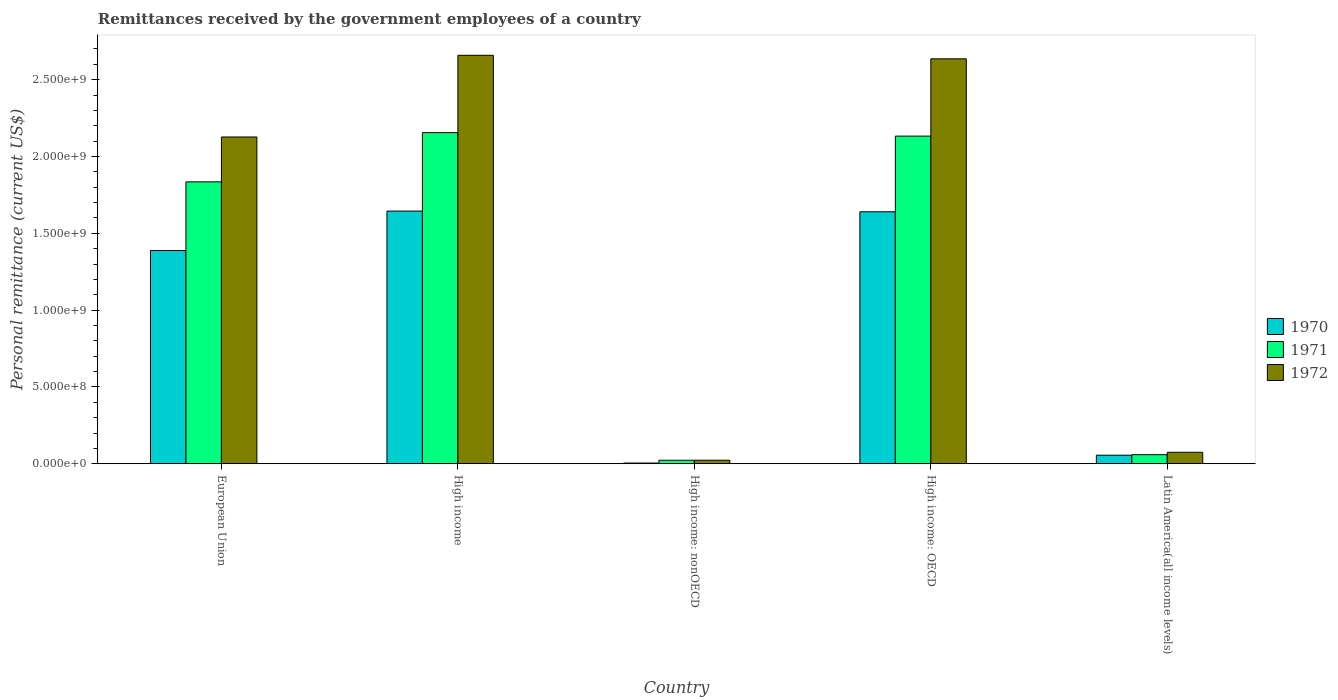Are the number of bars per tick equal to the number of legend labels?
Your answer should be very brief. Yes. Are the number of bars on each tick of the X-axis equal?
Provide a short and direct response. Yes. How many bars are there on the 4th tick from the left?
Your answer should be very brief. 3. How many bars are there on the 5th tick from the right?
Your response must be concise. 3. What is the label of the 5th group of bars from the left?
Provide a short and direct response. Latin America(all income levels). In how many cases, is the number of bars for a given country not equal to the number of legend labels?
Offer a terse response. 0. What is the remittances received by the government employees in 1972 in High income: nonOECD?
Give a very brief answer. 2.29e+07. Across all countries, what is the maximum remittances received by the government employees in 1971?
Offer a very short reply. 2.16e+09. Across all countries, what is the minimum remittances received by the government employees in 1971?
Provide a short and direct response. 2.28e+07. In which country was the remittances received by the government employees in 1971 maximum?
Make the answer very short. High income. In which country was the remittances received by the government employees in 1970 minimum?
Make the answer very short. High income: nonOECD. What is the total remittances received by the government employees in 1970 in the graph?
Your answer should be very brief. 4.73e+09. What is the difference between the remittances received by the government employees in 1972 in High income and that in High income: OECD?
Offer a terse response. 2.29e+07. What is the difference between the remittances received by the government employees in 1970 in High income: nonOECD and the remittances received by the government employees in 1971 in High income: OECD?
Ensure brevity in your answer.  -2.13e+09. What is the average remittances received by the government employees in 1971 per country?
Keep it short and to the point. 1.24e+09. What is the difference between the remittances received by the government employees of/in 1970 and remittances received by the government employees of/in 1971 in Latin America(all income levels)?
Provide a succinct answer. -3.57e+06. In how many countries, is the remittances received by the government employees in 1972 greater than 1200000000 US$?
Your response must be concise. 3. What is the ratio of the remittances received by the government employees in 1971 in European Union to that in High income: nonOECD?
Keep it short and to the point. 80.52. Is the difference between the remittances received by the government employees in 1970 in High income: OECD and Latin America(all income levels) greater than the difference between the remittances received by the government employees in 1971 in High income: OECD and Latin America(all income levels)?
Keep it short and to the point. No. What is the difference between the highest and the second highest remittances received by the government employees in 1971?
Your answer should be compact. 2.98e+08. What is the difference between the highest and the lowest remittances received by the government employees in 1972?
Provide a short and direct response. 2.64e+09. Is the sum of the remittances received by the government employees in 1971 in High income: OECD and Latin America(all income levels) greater than the maximum remittances received by the government employees in 1972 across all countries?
Provide a succinct answer. No. What does the 3rd bar from the left in High income represents?
Your response must be concise. 1972. Is it the case that in every country, the sum of the remittances received by the government employees in 1971 and remittances received by the government employees in 1972 is greater than the remittances received by the government employees in 1970?
Ensure brevity in your answer.  Yes. How many countries are there in the graph?
Ensure brevity in your answer.  5. Are the values on the major ticks of Y-axis written in scientific E-notation?
Your answer should be very brief. Yes. Does the graph contain any zero values?
Offer a very short reply. No. Does the graph contain grids?
Offer a terse response. No. What is the title of the graph?
Your response must be concise. Remittances received by the government employees of a country. What is the label or title of the X-axis?
Provide a succinct answer. Country. What is the label or title of the Y-axis?
Offer a terse response. Personal remittance (current US$). What is the Personal remittance (current US$) in 1970 in European Union?
Your answer should be very brief. 1.39e+09. What is the Personal remittance (current US$) in 1971 in European Union?
Keep it short and to the point. 1.83e+09. What is the Personal remittance (current US$) in 1972 in European Union?
Make the answer very short. 2.13e+09. What is the Personal remittance (current US$) in 1970 in High income?
Your response must be concise. 1.64e+09. What is the Personal remittance (current US$) of 1971 in High income?
Your response must be concise. 2.16e+09. What is the Personal remittance (current US$) in 1972 in High income?
Offer a very short reply. 2.66e+09. What is the Personal remittance (current US$) of 1970 in High income: nonOECD?
Give a very brief answer. 4.40e+06. What is the Personal remittance (current US$) of 1971 in High income: nonOECD?
Your answer should be compact. 2.28e+07. What is the Personal remittance (current US$) in 1972 in High income: nonOECD?
Your response must be concise. 2.29e+07. What is the Personal remittance (current US$) of 1970 in High income: OECD?
Make the answer very short. 1.64e+09. What is the Personal remittance (current US$) in 1971 in High income: OECD?
Your answer should be very brief. 2.13e+09. What is the Personal remittance (current US$) of 1972 in High income: OECD?
Make the answer very short. 2.64e+09. What is the Personal remittance (current US$) of 1970 in Latin America(all income levels)?
Offer a terse response. 5.55e+07. What is the Personal remittance (current US$) of 1971 in Latin America(all income levels)?
Provide a succinct answer. 5.91e+07. What is the Personal remittance (current US$) in 1972 in Latin America(all income levels)?
Provide a short and direct response. 7.45e+07. Across all countries, what is the maximum Personal remittance (current US$) in 1970?
Make the answer very short. 1.64e+09. Across all countries, what is the maximum Personal remittance (current US$) in 1971?
Your answer should be compact. 2.16e+09. Across all countries, what is the maximum Personal remittance (current US$) in 1972?
Keep it short and to the point. 2.66e+09. Across all countries, what is the minimum Personal remittance (current US$) in 1970?
Your answer should be very brief. 4.40e+06. Across all countries, what is the minimum Personal remittance (current US$) in 1971?
Keep it short and to the point. 2.28e+07. Across all countries, what is the minimum Personal remittance (current US$) in 1972?
Your answer should be very brief. 2.29e+07. What is the total Personal remittance (current US$) of 1970 in the graph?
Offer a very short reply. 4.73e+09. What is the total Personal remittance (current US$) in 1971 in the graph?
Your answer should be compact. 6.20e+09. What is the total Personal remittance (current US$) of 1972 in the graph?
Your answer should be very brief. 7.52e+09. What is the difference between the Personal remittance (current US$) of 1970 in European Union and that in High income?
Offer a terse response. -2.57e+08. What is the difference between the Personal remittance (current US$) in 1971 in European Union and that in High income?
Provide a short and direct response. -3.21e+08. What is the difference between the Personal remittance (current US$) in 1972 in European Union and that in High income?
Offer a very short reply. -5.32e+08. What is the difference between the Personal remittance (current US$) in 1970 in European Union and that in High income: nonOECD?
Offer a terse response. 1.38e+09. What is the difference between the Personal remittance (current US$) of 1971 in European Union and that in High income: nonOECD?
Give a very brief answer. 1.81e+09. What is the difference between the Personal remittance (current US$) in 1972 in European Union and that in High income: nonOECD?
Provide a short and direct response. 2.10e+09. What is the difference between the Personal remittance (current US$) of 1970 in European Union and that in High income: OECD?
Provide a succinct answer. -2.52e+08. What is the difference between the Personal remittance (current US$) in 1971 in European Union and that in High income: OECD?
Give a very brief answer. -2.98e+08. What is the difference between the Personal remittance (current US$) in 1972 in European Union and that in High income: OECD?
Offer a terse response. -5.09e+08. What is the difference between the Personal remittance (current US$) in 1970 in European Union and that in Latin America(all income levels)?
Give a very brief answer. 1.33e+09. What is the difference between the Personal remittance (current US$) in 1971 in European Union and that in Latin America(all income levels)?
Keep it short and to the point. 1.78e+09. What is the difference between the Personal remittance (current US$) in 1972 in European Union and that in Latin America(all income levels)?
Offer a very short reply. 2.05e+09. What is the difference between the Personal remittance (current US$) of 1970 in High income and that in High income: nonOECD?
Ensure brevity in your answer.  1.64e+09. What is the difference between the Personal remittance (current US$) of 1971 in High income and that in High income: nonOECD?
Offer a terse response. 2.13e+09. What is the difference between the Personal remittance (current US$) in 1972 in High income and that in High income: nonOECD?
Make the answer very short. 2.64e+09. What is the difference between the Personal remittance (current US$) in 1970 in High income and that in High income: OECD?
Provide a short and direct response. 4.40e+06. What is the difference between the Personal remittance (current US$) of 1971 in High income and that in High income: OECD?
Offer a terse response. 2.28e+07. What is the difference between the Personal remittance (current US$) in 1972 in High income and that in High income: OECD?
Provide a succinct answer. 2.29e+07. What is the difference between the Personal remittance (current US$) of 1970 in High income and that in Latin America(all income levels)?
Make the answer very short. 1.59e+09. What is the difference between the Personal remittance (current US$) of 1971 in High income and that in Latin America(all income levels)?
Give a very brief answer. 2.10e+09. What is the difference between the Personal remittance (current US$) in 1972 in High income and that in Latin America(all income levels)?
Offer a very short reply. 2.58e+09. What is the difference between the Personal remittance (current US$) of 1970 in High income: nonOECD and that in High income: OECD?
Your response must be concise. -1.64e+09. What is the difference between the Personal remittance (current US$) of 1971 in High income: nonOECD and that in High income: OECD?
Offer a very short reply. -2.11e+09. What is the difference between the Personal remittance (current US$) of 1972 in High income: nonOECD and that in High income: OECD?
Give a very brief answer. -2.61e+09. What is the difference between the Personal remittance (current US$) in 1970 in High income: nonOECD and that in Latin America(all income levels)?
Ensure brevity in your answer.  -5.11e+07. What is the difference between the Personal remittance (current US$) in 1971 in High income: nonOECD and that in Latin America(all income levels)?
Keep it short and to the point. -3.63e+07. What is the difference between the Personal remittance (current US$) of 1972 in High income: nonOECD and that in Latin America(all income levels)?
Your answer should be compact. -5.16e+07. What is the difference between the Personal remittance (current US$) of 1970 in High income: OECD and that in Latin America(all income levels)?
Your answer should be compact. 1.58e+09. What is the difference between the Personal remittance (current US$) in 1971 in High income: OECD and that in Latin America(all income levels)?
Your answer should be compact. 2.07e+09. What is the difference between the Personal remittance (current US$) in 1972 in High income: OECD and that in Latin America(all income levels)?
Ensure brevity in your answer.  2.56e+09. What is the difference between the Personal remittance (current US$) in 1970 in European Union and the Personal remittance (current US$) in 1971 in High income?
Keep it short and to the point. -7.68e+08. What is the difference between the Personal remittance (current US$) in 1970 in European Union and the Personal remittance (current US$) in 1972 in High income?
Your answer should be compact. -1.27e+09. What is the difference between the Personal remittance (current US$) of 1971 in European Union and the Personal remittance (current US$) of 1972 in High income?
Your answer should be very brief. -8.24e+08. What is the difference between the Personal remittance (current US$) in 1970 in European Union and the Personal remittance (current US$) in 1971 in High income: nonOECD?
Keep it short and to the point. 1.37e+09. What is the difference between the Personal remittance (current US$) of 1970 in European Union and the Personal remittance (current US$) of 1972 in High income: nonOECD?
Provide a short and direct response. 1.36e+09. What is the difference between the Personal remittance (current US$) of 1971 in European Union and the Personal remittance (current US$) of 1972 in High income: nonOECD?
Provide a short and direct response. 1.81e+09. What is the difference between the Personal remittance (current US$) in 1970 in European Union and the Personal remittance (current US$) in 1971 in High income: OECD?
Your answer should be compact. -7.45e+08. What is the difference between the Personal remittance (current US$) of 1970 in European Union and the Personal remittance (current US$) of 1972 in High income: OECD?
Your answer should be very brief. -1.25e+09. What is the difference between the Personal remittance (current US$) of 1971 in European Union and the Personal remittance (current US$) of 1972 in High income: OECD?
Your answer should be very brief. -8.01e+08. What is the difference between the Personal remittance (current US$) of 1970 in European Union and the Personal remittance (current US$) of 1971 in Latin America(all income levels)?
Offer a very short reply. 1.33e+09. What is the difference between the Personal remittance (current US$) of 1970 in European Union and the Personal remittance (current US$) of 1972 in Latin America(all income levels)?
Your response must be concise. 1.31e+09. What is the difference between the Personal remittance (current US$) of 1971 in European Union and the Personal remittance (current US$) of 1972 in Latin America(all income levels)?
Keep it short and to the point. 1.76e+09. What is the difference between the Personal remittance (current US$) in 1970 in High income and the Personal remittance (current US$) in 1971 in High income: nonOECD?
Provide a short and direct response. 1.62e+09. What is the difference between the Personal remittance (current US$) of 1970 in High income and the Personal remittance (current US$) of 1972 in High income: nonOECD?
Provide a short and direct response. 1.62e+09. What is the difference between the Personal remittance (current US$) of 1971 in High income and the Personal remittance (current US$) of 1972 in High income: nonOECD?
Ensure brevity in your answer.  2.13e+09. What is the difference between the Personal remittance (current US$) of 1970 in High income and the Personal remittance (current US$) of 1971 in High income: OECD?
Give a very brief answer. -4.88e+08. What is the difference between the Personal remittance (current US$) of 1970 in High income and the Personal remittance (current US$) of 1972 in High income: OECD?
Provide a succinct answer. -9.91e+08. What is the difference between the Personal remittance (current US$) in 1971 in High income and the Personal remittance (current US$) in 1972 in High income: OECD?
Keep it short and to the point. -4.80e+08. What is the difference between the Personal remittance (current US$) of 1970 in High income and the Personal remittance (current US$) of 1971 in Latin America(all income levels)?
Provide a succinct answer. 1.59e+09. What is the difference between the Personal remittance (current US$) of 1970 in High income and the Personal remittance (current US$) of 1972 in Latin America(all income levels)?
Offer a very short reply. 1.57e+09. What is the difference between the Personal remittance (current US$) of 1971 in High income and the Personal remittance (current US$) of 1972 in Latin America(all income levels)?
Ensure brevity in your answer.  2.08e+09. What is the difference between the Personal remittance (current US$) of 1970 in High income: nonOECD and the Personal remittance (current US$) of 1971 in High income: OECD?
Keep it short and to the point. -2.13e+09. What is the difference between the Personal remittance (current US$) in 1970 in High income: nonOECD and the Personal remittance (current US$) in 1972 in High income: OECD?
Offer a very short reply. -2.63e+09. What is the difference between the Personal remittance (current US$) in 1971 in High income: nonOECD and the Personal remittance (current US$) in 1972 in High income: OECD?
Your answer should be compact. -2.61e+09. What is the difference between the Personal remittance (current US$) in 1970 in High income: nonOECD and the Personal remittance (current US$) in 1971 in Latin America(all income levels)?
Provide a short and direct response. -5.47e+07. What is the difference between the Personal remittance (current US$) in 1970 in High income: nonOECD and the Personal remittance (current US$) in 1972 in Latin America(all income levels)?
Ensure brevity in your answer.  -7.01e+07. What is the difference between the Personal remittance (current US$) in 1971 in High income: nonOECD and the Personal remittance (current US$) in 1972 in Latin America(all income levels)?
Provide a succinct answer. -5.17e+07. What is the difference between the Personal remittance (current US$) of 1970 in High income: OECD and the Personal remittance (current US$) of 1971 in Latin America(all income levels)?
Your response must be concise. 1.58e+09. What is the difference between the Personal remittance (current US$) of 1970 in High income: OECD and the Personal remittance (current US$) of 1972 in Latin America(all income levels)?
Offer a very short reply. 1.57e+09. What is the difference between the Personal remittance (current US$) of 1971 in High income: OECD and the Personal remittance (current US$) of 1972 in Latin America(all income levels)?
Offer a very short reply. 2.06e+09. What is the average Personal remittance (current US$) of 1970 per country?
Provide a short and direct response. 9.46e+08. What is the average Personal remittance (current US$) in 1971 per country?
Your response must be concise. 1.24e+09. What is the average Personal remittance (current US$) of 1972 per country?
Provide a succinct answer. 1.50e+09. What is the difference between the Personal remittance (current US$) of 1970 and Personal remittance (current US$) of 1971 in European Union?
Provide a short and direct response. -4.47e+08. What is the difference between the Personal remittance (current US$) of 1970 and Personal remittance (current US$) of 1972 in European Union?
Give a very brief answer. -7.39e+08. What is the difference between the Personal remittance (current US$) in 1971 and Personal remittance (current US$) in 1972 in European Union?
Give a very brief answer. -2.92e+08. What is the difference between the Personal remittance (current US$) of 1970 and Personal remittance (current US$) of 1971 in High income?
Provide a succinct answer. -5.11e+08. What is the difference between the Personal remittance (current US$) of 1970 and Personal remittance (current US$) of 1972 in High income?
Offer a very short reply. -1.01e+09. What is the difference between the Personal remittance (current US$) of 1971 and Personal remittance (current US$) of 1972 in High income?
Provide a succinct answer. -5.03e+08. What is the difference between the Personal remittance (current US$) in 1970 and Personal remittance (current US$) in 1971 in High income: nonOECD?
Your answer should be compact. -1.84e+07. What is the difference between the Personal remittance (current US$) of 1970 and Personal remittance (current US$) of 1972 in High income: nonOECD?
Provide a succinct answer. -1.85e+07. What is the difference between the Personal remittance (current US$) in 1971 and Personal remittance (current US$) in 1972 in High income: nonOECD?
Your answer should be compact. -1.37e+05. What is the difference between the Personal remittance (current US$) in 1970 and Personal remittance (current US$) in 1971 in High income: OECD?
Your answer should be compact. -4.92e+08. What is the difference between the Personal remittance (current US$) of 1970 and Personal remittance (current US$) of 1972 in High income: OECD?
Your answer should be compact. -9.96e+08. What is the difference between the Personal remittance (current US$) in 1971 and Personal remittance (current US$) in 1972 in High income: OECD?
Offer a terse response. -5.03e+08. What is the difference between the Personal remittance (current US$) in 1970 and Personal remittance (current US$) in 1971 in Latin America(all income levels)?
Your answer should be very brief. -3.57e+06. What is the difference between the Personal remittance (current US$) in 1970 and Personal remittance (current US$) in 1972 in Latin America(all income levels)?
Offer a terse response. -1.90e+07. What is the difference between the Personal remittance (current US$) in 1971 and Personal remittance (current US$) in 1972 in Latin America(all income levels)?
Give a very brief answer. -1.54e+07. What is the ratio of the Personal remittance (current US$) of 1970 in European Union to that in High income?
Provide a succinct answer. 0.84. What is the ratio of the Personal remittance (current US$) of 1971 in European Union to that in High income?
Your response must be concise. 0.85. What is the ratio of the Personal remittance (current US$) of 1970 in European Union to that in High income: nonOECD?
Provide a succinct answer. 315.41. What is the ratio of the Personal remittance (current US$) of 1971 in European Union to that in High income: nonOECD?
Keep it short and to the point. 80.52. What is the ratio of the Personal remittance (current US$) of 1972 in European Union to that in High income: nonOECD?
Your answer should be compact. 92.79. What is the ratio of the Personal remittance (current US$) in 1970 in European Union to that in High income: OECD?
Your answer should be compact. 0.85. What is the ratio of the Personal remittance (current US$) of 1971 in European Union to that in High income: OECD?
Your answer should be compact. 0.86. What is the ratio of the Personal remittance (current US$) in 1972 in European Union to that in High income: OECD?
Provide a short and direct response. 0.81. What is the ratio of the Personal remittance (current US$) of 1970 in European Union to that in Latin America(all income levels)?
Your answer should be very brief. 25.01. What is the ratio of the Personal remittance (current US$) of 1971 in European Union to that in Latin America(all income levels)?
Offer a very short reply. 31.06. What is the ratio of the Personal remittance (current US$) in 1972 in European Union to that in Latin America(all income levels)?
Your answer should be very brief. 28.56. What is the ratio of the Personal remittance (current US$) in 1970 in High income to that in High income: nonOECD?
Keep it short and to the point. 373.75. What is the ratio of the Personal remittance (current US$) in 1971 in High income to that in High income: nonOECD?
Offer a terse response. 94.6. What is the ratio of the Personal remittance (current US$) of 1972 in High income to that in High income: nonOECD?
Keep it short and to the point. 115.99. What is the ratio of the Personal remittance (current US$) of 1970 in High income to that in High income: OECD?
Your answer should be very brief. 1. What is the ratio of the Personal remittance (current US$) of 1971 in High income to that in High income: OECD?
Make the answer very short. 1.01. What is the ratio of the Personal remittance (current US$) of 1972 in High income to that in High income: OECD?
Offer a terse response. 1.01. What is the ratio of the Personal remittance (current US$) of 1970 in High income to that in Latin America(all income levels)?
Your answer should be very brief. 29.63. What is the ratio of the Personal remittance (current US$) in 1971 in High income to that in Latin America(all income levels)?
Offer a terse response. 36.49. What is the ratio of the Personal remittance (current US$) of 1972 in High income to that in Latin America(all income levels)?
Your response must be concise. 35.7. What is the ratio of the Personal remittance (current US$) of 1970 in High income: nonOECD to that in High income: OECD?
Offer a very short reply. 0. What is the ratio of the Personal remittance (current US$) of 1971 in High income: nonOECD to that in High income: OECD?
Offer a very short reply. 0.01. What is the ratio of the Personal remittance (current US$) in 1972 in High income: nonOECD to that in High income: OECD?
Your response must be concise. 0.01. What is the ratio of the Personal remittance (current US$) in 1970 in High income: nonOECD to that in Latin America(all income levels)?
Provide a succinct answer. 0.08. What is the ratio of the Personal remittance (current US$) in 1971 in High income: nonOECD to that in Latin America(all income levels)?
Your answer should be very brief. 0.39. What is the ratio of the Personal remittance (current US$) in 1972 in High income: nonOECD to that in Latin America(all income levels)?
Your answer should be very brief. 0.31. What is the ratio of the Personal remittance (current US$) of 1970 in High income: OECD to that in Latin America(all income levels)?
Keep it short and to the point. 29.55. What is the ratio of the Personal remittance (current US$) of 1971 in High income: OECD to that in Latin America(all income levels)?
Offer a terse response. 36.1. What is the ratio of the Personal remittance (current US$) of 1972 in High income: OECD to that in Latin America(all income levels)?
Ensure brevity in your answer.  35.39. What is the difference between the highest and the second highest Personal remittance (current US$) in 1970?
Offer a terse response. 4.40e+06. What is the difference between the highest and the second highest Personal remittance (current US$) in 1971?
Keep it short and to the point. 2.28e+07. What is the difference between the highest and the second highest Personal remittance (current US$) in 1972?
Provide a succinct answer. 2.29e+07. What is the difference between the highest and the lowest Personal remittance (current US$) in 1970?
Your answer should be very brief. 1.64e+09. What is the difference between the highest and the lowest Personal remittance (current US$) of 1971?
Offer a very short reply. 2.13e+09. What is the difference between the highest and the lowest Personal remittance (current US$) of 1972?
Make the answer very short. 2.64e+09. 